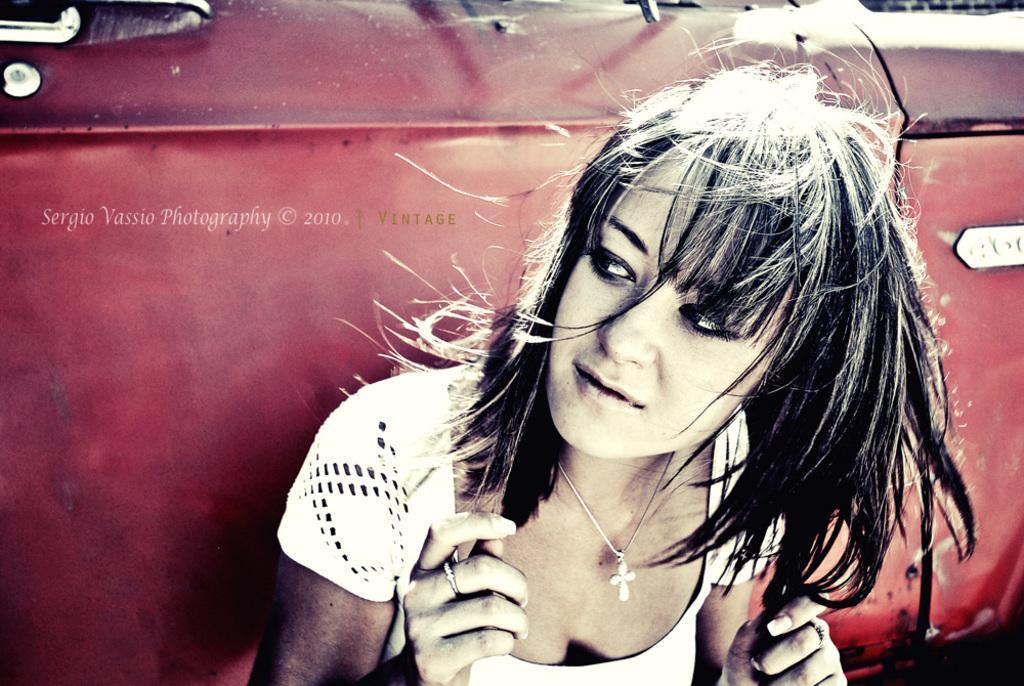Could you give a brief overview of what you see in this image? This picture shows a woman and we see a car on the back. It is red in color and we see a watermark on the top left corner. 